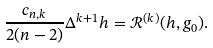<formula> <loc_0><loc_0><loc_500><loc_500>\frac { c _ { n , k } } { 2 ( n - 2 ) } \Delta ^ { k + 1 } h = \mathcal { R } ^ { ( k ) } ( h , g _ { 0 } ) .</formula> 